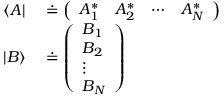<formula> <loc_0><loc_0><loc_500><loc_500>\begin{array} { r l } { \langle A | } & \doteq { \left ( \begin{array} { l l l l } { A _ { 1 } ^ { * } } & { A _ { 2 } ^ { * } } & { \cdots } & { A _ { N } ^ { * } } \end{array} \right ) } } \\ { | B \rangle } & \doteq { \left ( \begin{array} { l } { B _ { 1 } } \\ { B _ { 2 } } \\ { \vdots } \\ { B _ { N } } \end{array} \right ) } } \end{array}</formula> 